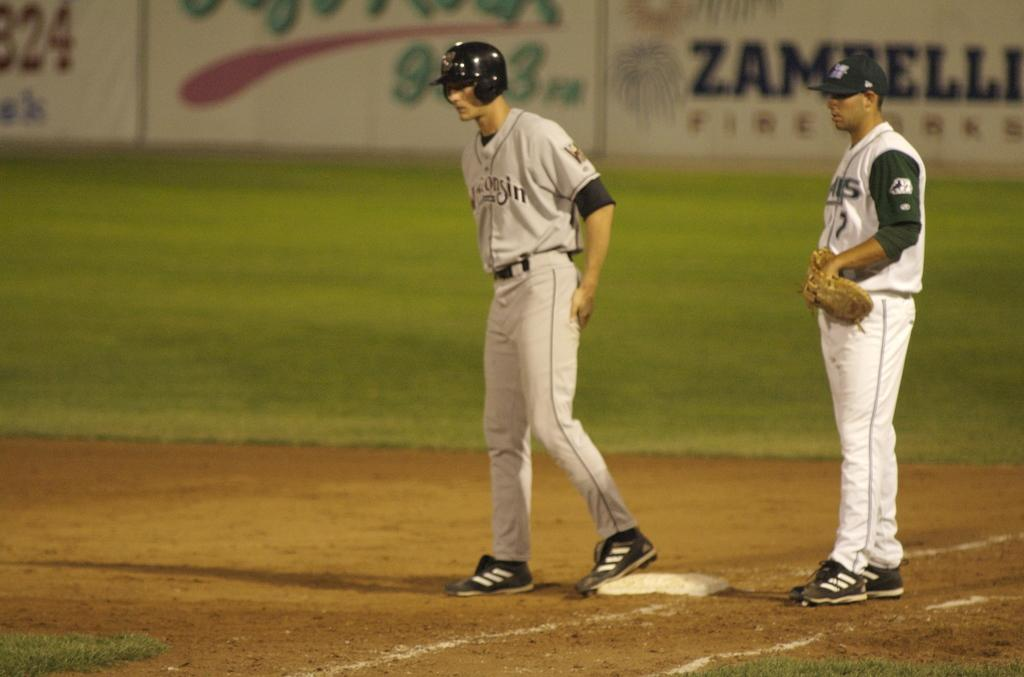<image>
Offer a succinct explanation of the picture presented. A player from Wisconsin stands on base, ready to run. 